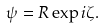Convert formula to latex. <formula><loc_0><loc_0><loc_500><loc_500>\psi = R \exp { i \zeta } .</formula> 